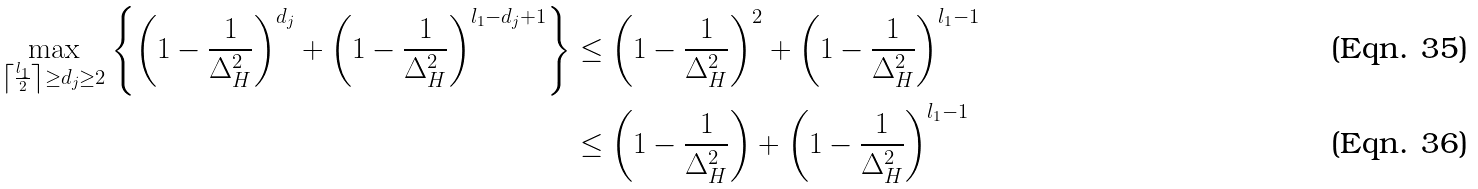Convert formula to latex. <formula><loc_0><loc_0><loc_500><loc_500>\max _ { \left \lceil \frac { l _ { 1 } } { 2 } \right \rceil \geq d _ { j } \geq 2 } \left \{ \left ( 1 - \frac { 1 } { \Delta _ { H } ^ { 2 } } \right ) ^ { d _ { j } } + \left ( 1 - \frac { 1 } { \Delta _ { H } ^ { 2 } } \right ) ^ { l _ { 1 } - d _ { j } + 1 } \right \} & \leq \left ( 1 - \frac { 1 } { \Delta _ { H } ^ { 2 } } \right ) ^ { 2 } + \left ( 1 - \frac { 1 } { \Delta _ { H } ^ { 2 } } \right ) ^ { l _ { 1 } - 1 } \\ & \leq \left ( 1 - \frac { 1 } { \Delta _ { H } ^ { 2 } } \right ) + \left ( 1 - \frac { 1 } { \Delta _ { H } ^ { 2 } } \right ) ^ { l _ { 1 } - 1 }</formula> 